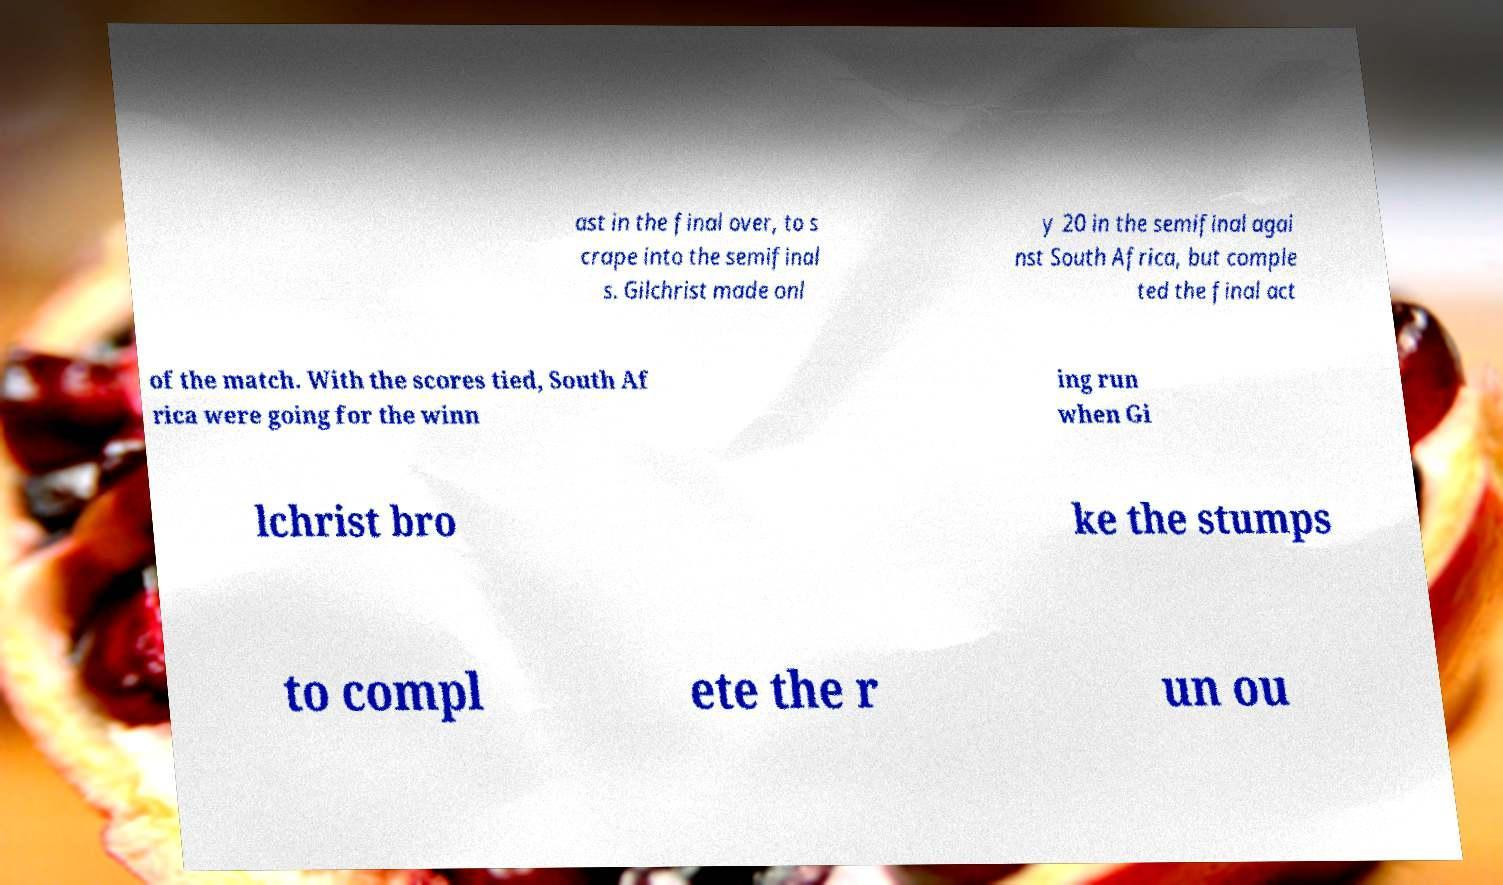Can you accurately transcribe the text from the provided image for me? ast in the final over, to s crape into the semifinal s. Gilchrist made onl y 20 in the semifinal agai nst South Africa, but comple ted the final act of the match. With the scores tied, South Af rica were going for the winn ing run when Gi lchrist bro ke the stumps to compl ete the r un ou 